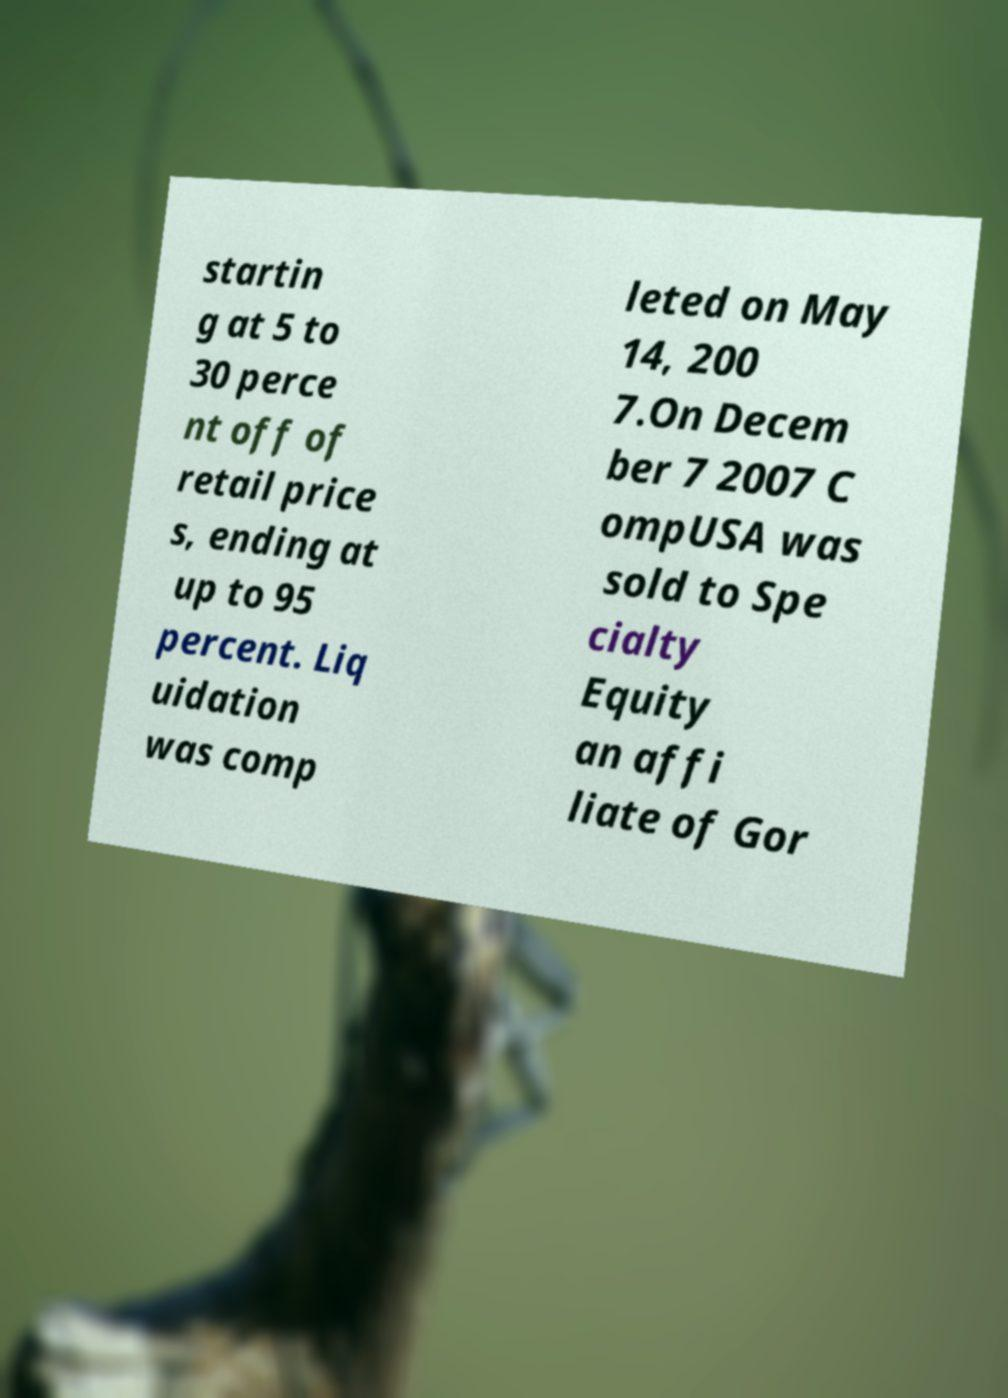I need the written content from this picture converted into text. Can you do that? startin g at 5 to 30 perce nt off of retail price s, ending at up to 95 percent. Liq uidation was comp leted on May 14, 200 7.On Decem ber 7 2007 C ompUSA was sold to Spe cialty Equity an affi liate of Gor 